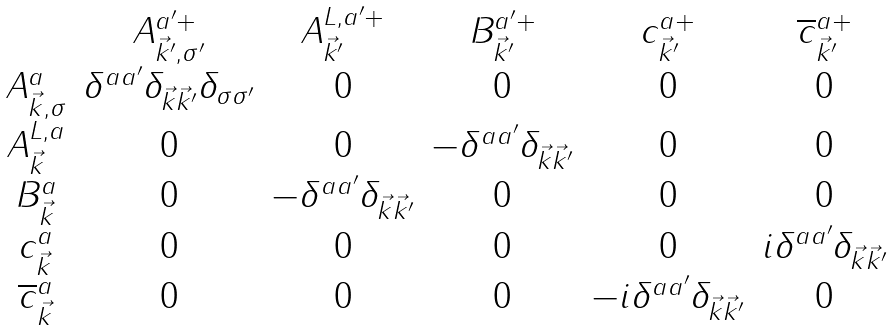Convert formula to latex. <formula><loc_0><loc_0><loc_500><loc_500>\begin{array} { c c c c c c } & A _ { \vec { k } ^ { \prime } , \sigma ^ { \prime } } ^ { a ^ { \prime } + } & A _ { \vec { k } ^ { \prime } } ^ { L , a ^ { \prime } + } & B _ { \vec { k } ^ { \prime } } ^ { a ^ { \prime } + } & c _ { \vec { k } ^ { \prime } } ^ { a + } & \overline { c } _ { \vec { k } ^ { \prime } } ^ { a + } \\ A _ { \vec { k } , \sigma } ^ { a } & \delta ^ { a a ^ { \prime } } \delta _ { \vec { k } \vec { k } ^ { \prime } } \delta _ { \sigma \sigma ^ { \prime } } & 0 & 0 & 0 & 0 \\ A _ { \vec { k } } ^ { L , a } & 0 & 0 & - \delta ^ { a a ^ { \prime } } \delta _ { \vec { k } \vec { k } ^ { \prime } } & 0 & 0 \\ B _ { \vec { k } } ^ { a } & 0 & - \delta ^ { a a ^ { \prime } } \delta _ { \vec { k } \vec { k } ^ { \prime } } & 0 & 0 & 0 \\ c _ { \vec { k } } ^ { a } & 0 & 0 & 0 & 0 & i \delta ^ { a a ^ { \prime } } \delta _ { \vec { k } \vec { k } ^ { \prime } } \\ \overline { c } _ { \vec { k } } ^ { a } & 0 & 0 & 0 & - i \delta ^ { a a ^ { \prime } } \delta _ { \vec { k } \vec { k } ^ { \prime } } & 0 \end{array}</formula> 